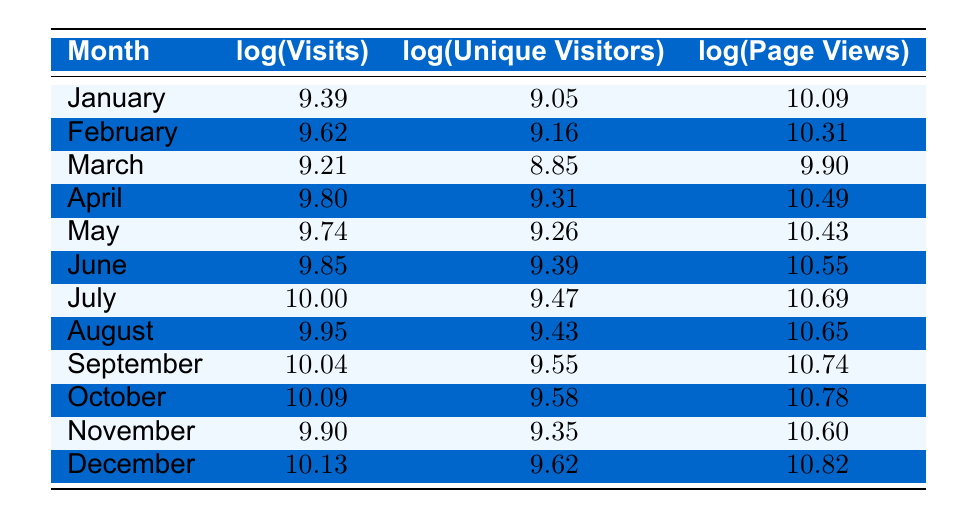What is the log(Visits) for July? In the table, we look for the row corresponding to July, which shows that the value of log(Visits) for that month is 10.00.
Answer: 10.00 Which month had the highest log(Page Views)? By scanning the log(Page Views) column, the maximum value is found in December, where log(Page Views) is 10.82.
Answer: December What is the difference between log(Visits) in October and January? We subtract log(Visits) for January (9.39) from log(Visits) for October (10.09): 10.09 - 9.39 = 0.70.
Answer: 0.70 Is the log(Unique Visitors) for November greater than that for March? Comparing the values, log(Unique Visitors) for November is 9.35 and for March is 8.85. Since 9.35 > 8.85, the statement is true.
Answer: Yes What is the average log(Page Views) for the first half of the year (January to June)? We add the log(Page Views) from January to June: 10.09 + 10.31 + 9.90 + 10.49 + 10.55 + 10.69 = 60.03, then divide by 6 (the number of months): 60.03 / 6 = 10.005.
Answer: 10.005 